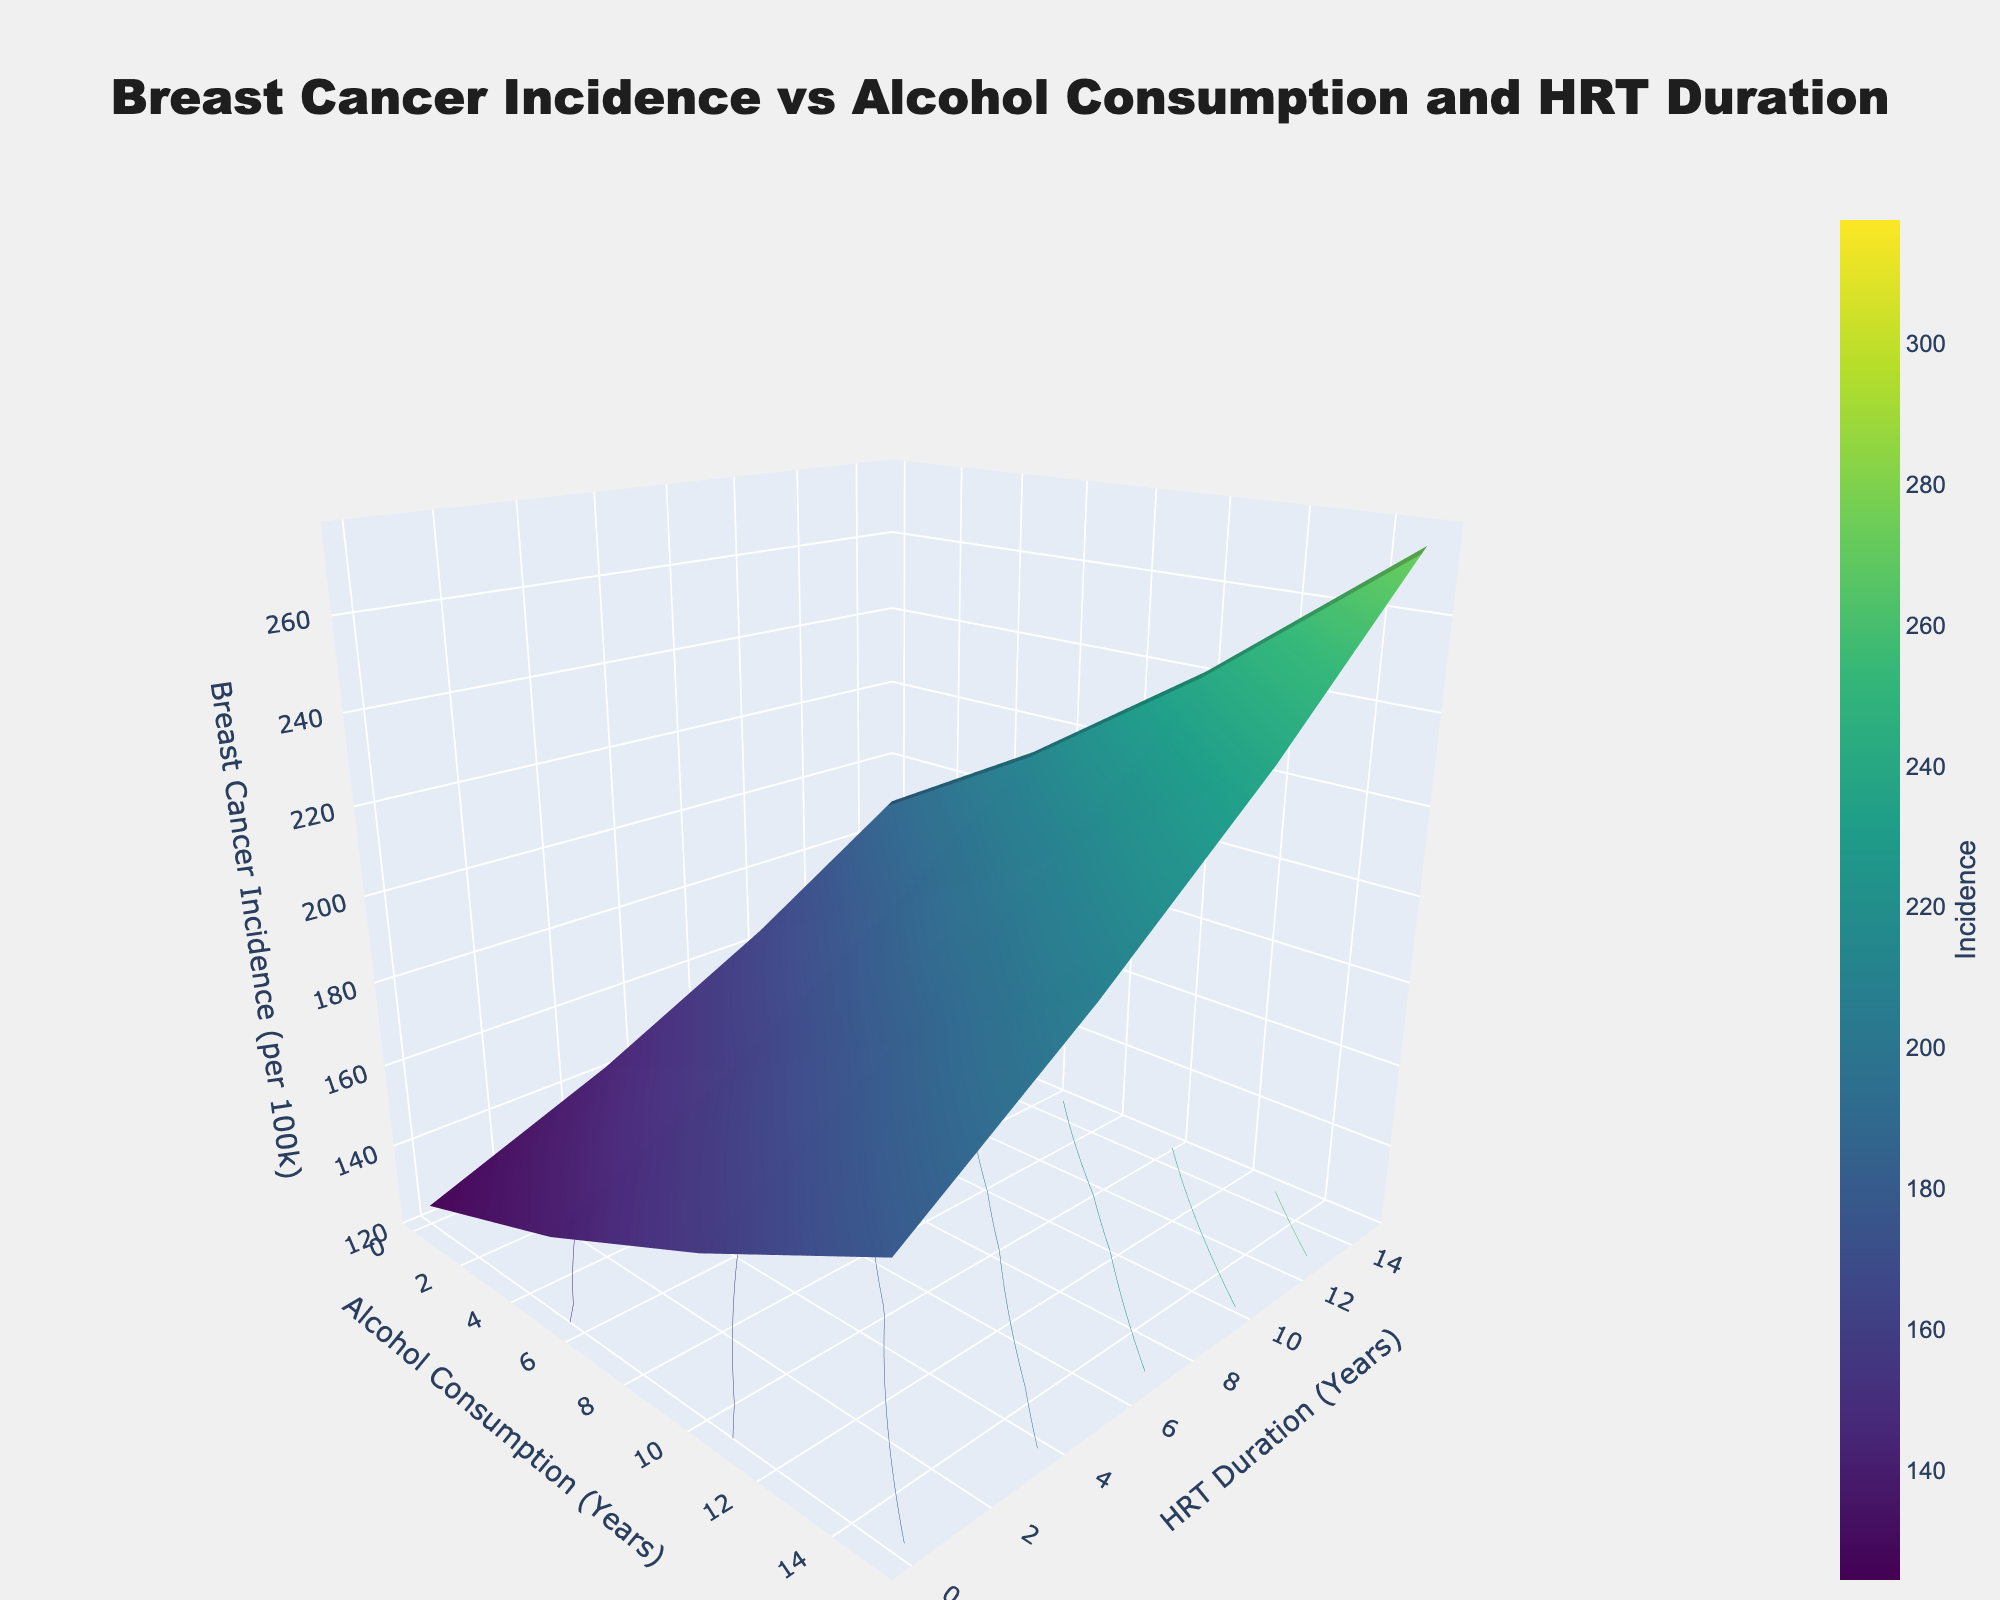What is the title of the graph? The title of the graph is usually displayed prominently at the top center. According to the provided code, the title is "Breast Cancer Incidence vs Alcohol Consumption and HRT Duration".
Answer: Breast Cancer Incidence vs Alcohol Consumption and HRT Duration Which axis represents alcohol consumption, and what are its units? The alcohol consumption axis is the X-axis, labeled "Alcohol Consumption (Years)". The unit specified is years.
Answer: Alcohol Consumption (Years) What does the color scale represent in this graph? The color scale represents the breast cancer incidence per 100,000 individuals. This is denoted by the changing colors through the 'Viridis' color scale, ranging from 124.5 to 317.5 as shown in the z-values.
Answer: Breast Cancer Incidence (per 100k) How does breast cancer incidence per 100,000 change with an increase in alcohol consumption but 0 years of HRT duration? By examining the surface plot, we see the trend along the x-axis (Alcohol Consumption) with y (HRT Duration) set to 0. The incidence rates increase as follows: 124.5 at 0 years of alcohol, 142.1 at 5 years, 163.7 at 10 years, 189.2 at 15 years, and 218.6 at 20 years.
Answer: It increases What is the breast cancer incidence rate for 10 years of alcohol consumption and 5 years of HRT duration? We locate the intersection at x=10 (Alcohol Consumption) and y=5 (HRT Duration) on the plot. The z-value at this point, representing breast cancer incidence, is 184.5 per 100,000.
Answer: 184.5 At what combination of alcohol consumption years and HRT duration years is the breast cancer incidence rate highest? To find the highest incidence, we look for the peak value on the surface plot. The highest rate of 317.5 per 100,000 occurs at 20 years of alcohol consumption and 15 years of HRT duration.
Answer: 20 years of alcohol consumption and 15 years of HRT duration Compare the breast cancer incidence rates between 5 years of alcohol consumption with 5 and 15 years of HRT duration. Which one is higher? By examining the z-values for the combination of 5 years of alcohol, we see 159.8 for 5 years of HRT and 206.9 for 15 years of HRT. Clearly, 206.9 (15 years of HRT) is higher than 159.8 (5 years of HRT).
Answer: 15 years of HRT duration Calculate the overall change in breast cancer incidence per 100,000 from 0 to 20 years of alcohol consumption at 10 years of HRT duration. The incidence rate at 0 years of alcohol consumption and 10 years of HRT is 156.7. At 20 years of alcohol consumption and 10 years of HRT, it is 279.3. The increase is 279.3 - 156.7 = 122.6.
Answer: 122.6 Is there a visible trend between alcohol consumption and breast cancer incidence regardless of HRT duration? Observing the surface plot, as we move along the x-axis (Alcohol Consumption), the breast cancer incidence consistently increases, indicating a direct relationship regardless of the HRT duration set by the y-axis.
Answer: Yes What's the difference in breast cancer incidence rates between 0 years and 20 years of alcohol consumption with 0 years of HRT duration? The incidence rate at 0 years of alcohol consumption is 124.5 per 100,000, whereas it’s 218.6 at 20 years. The difference is 218.6 - 124.5 = 94.1.
Answer: 94.1 